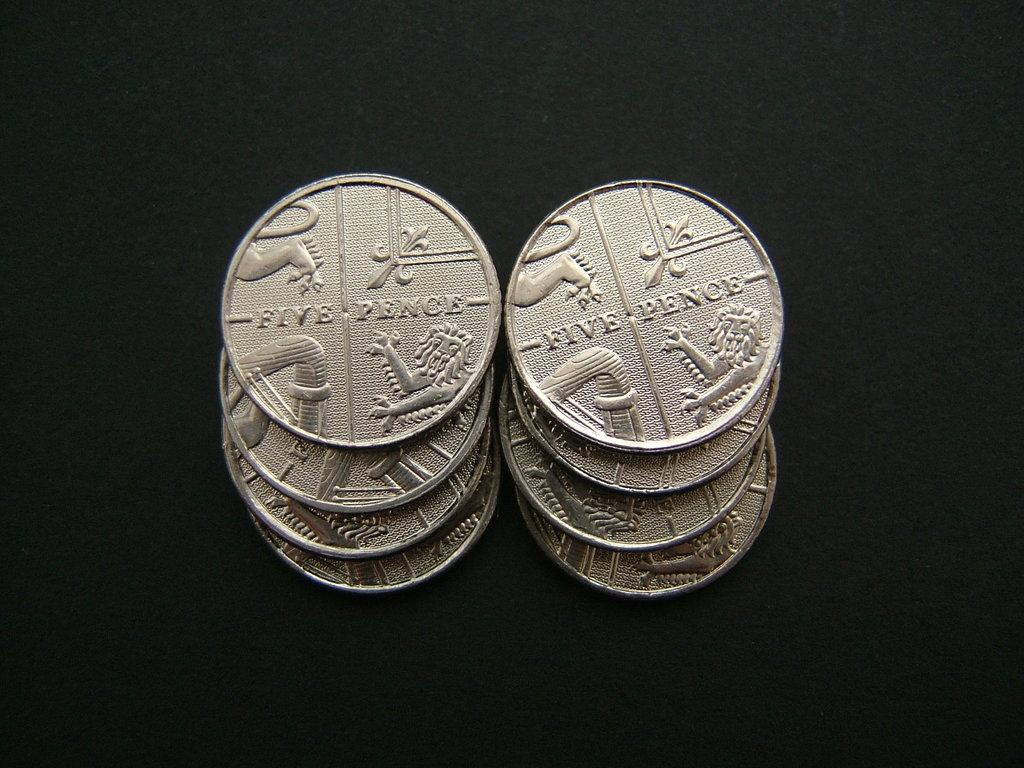<image>
Render a clear and concise summary of the photo. two stacks of four silver coins with the words 'five pence' on them 